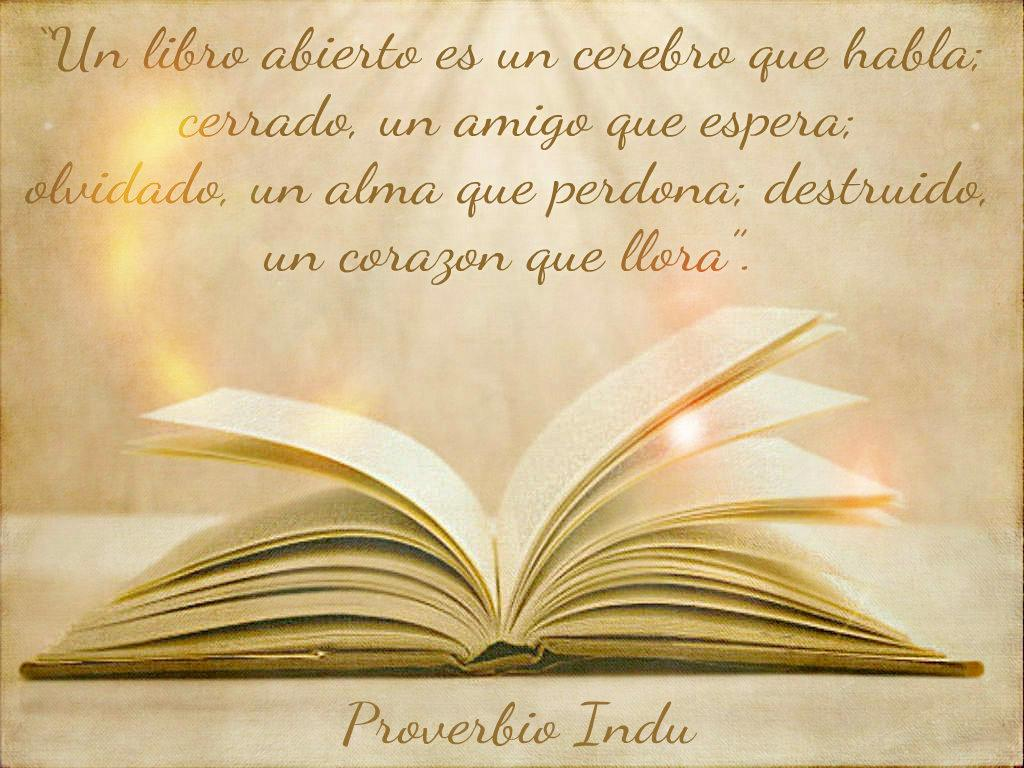Provide a one-sentence caption for the provided image. An open bible displays a verse from Proverbs. 